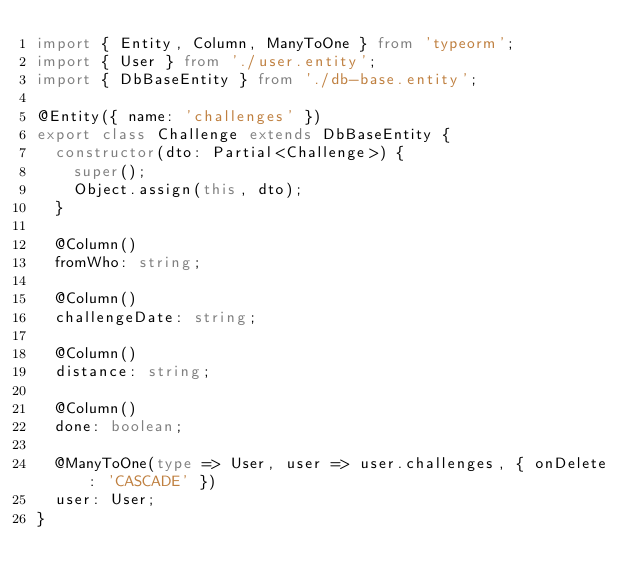Convert code to text. <code><loc_0><loc_0><loc_500><loc_500><_TypeScript_>import { Entity, Column, ManyToOne } from 'typeorm';
import { User } from './user.entity';
import { DbBaseEntity } from './db-base.entity';

@Entity({ name: 'challenges' })
export class Challenge extends DbBaseEntity {
  constructor(dto: Partial<Challenge>) {
    super();
    Object.assign(this, dto);
  }

  @Column()
  fromWho: string;

  @Column()
  challengeDate: string;

  @Column()
  distance: string;

  @Column()
  done: boolean;

  @ManyToOne(type => User, user => user.challenges, { onDelete: 'CASCADE' })
  user: User;
}
</code> 